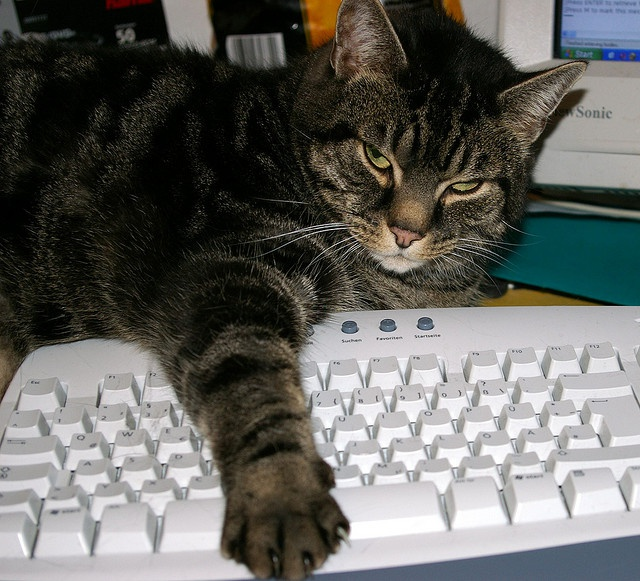Describe the objects in this image and their specific colors. I can see cat in purple, black, and gray tones, keyboard in purple, lightgray, darkgray, and gray tones, and tv in purple, darkgray, black, and gray tones in this image. 